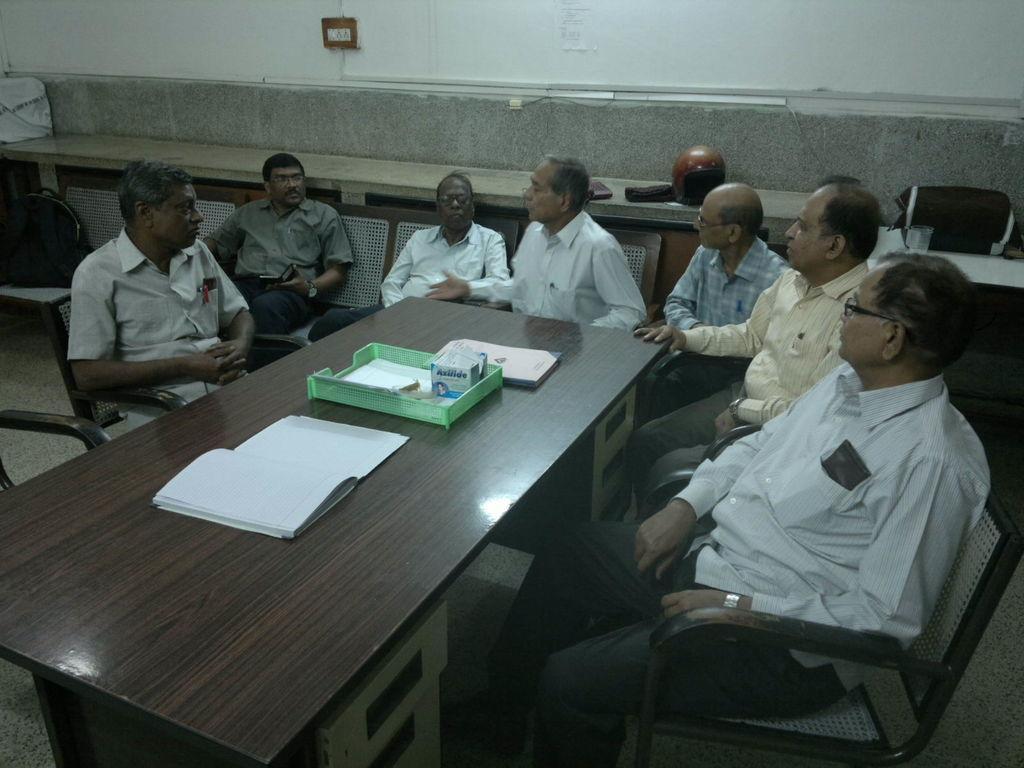Can you describe this image briefly? In this image in the middle there is a table on there are books and box, around the table there are many people sitting. On the right there is a man and he wears shirt, trouser and watch. On the left is a man he wears shirt he is sitting. In the background there are many chairs, bag, table glass and wall. 